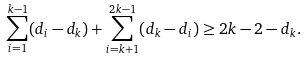<formula> <loc_0><loc_0><loc_500><loc_500>\sum _ { i = 1 } ^ { k - 1 } ( d _ { i } - d _ { k } ) + \sum _ { i = k + 1 } ^ { 2 k - 1 } ( d _ { k } - d _ { i } ) \geq 2 k - 2 - d _ { k } .</formula> 